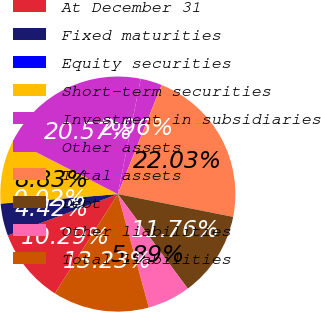<chart> <loc_0><loc_0><loc_500><loc_500><pie_chart><fcel>At December 31<fcel>Fixed maturities<fcel>Equity securities<fcel>Short-term securities<fcel>Investment in subsidiaries<fcel>Other assets<fcel>Total assets<fcel>Debt<fcel>Other liabilities<fcel>Total liabilities<nl><fcel>10.29%<fcel>4.42%<fcel>0.02%<fcel>8.83%<fcel>20.57%<fcel>2.96%<fcel>22.03%<fcel>11.76%<fcel>5.89%<fcel>13.23%<nl></chart> 